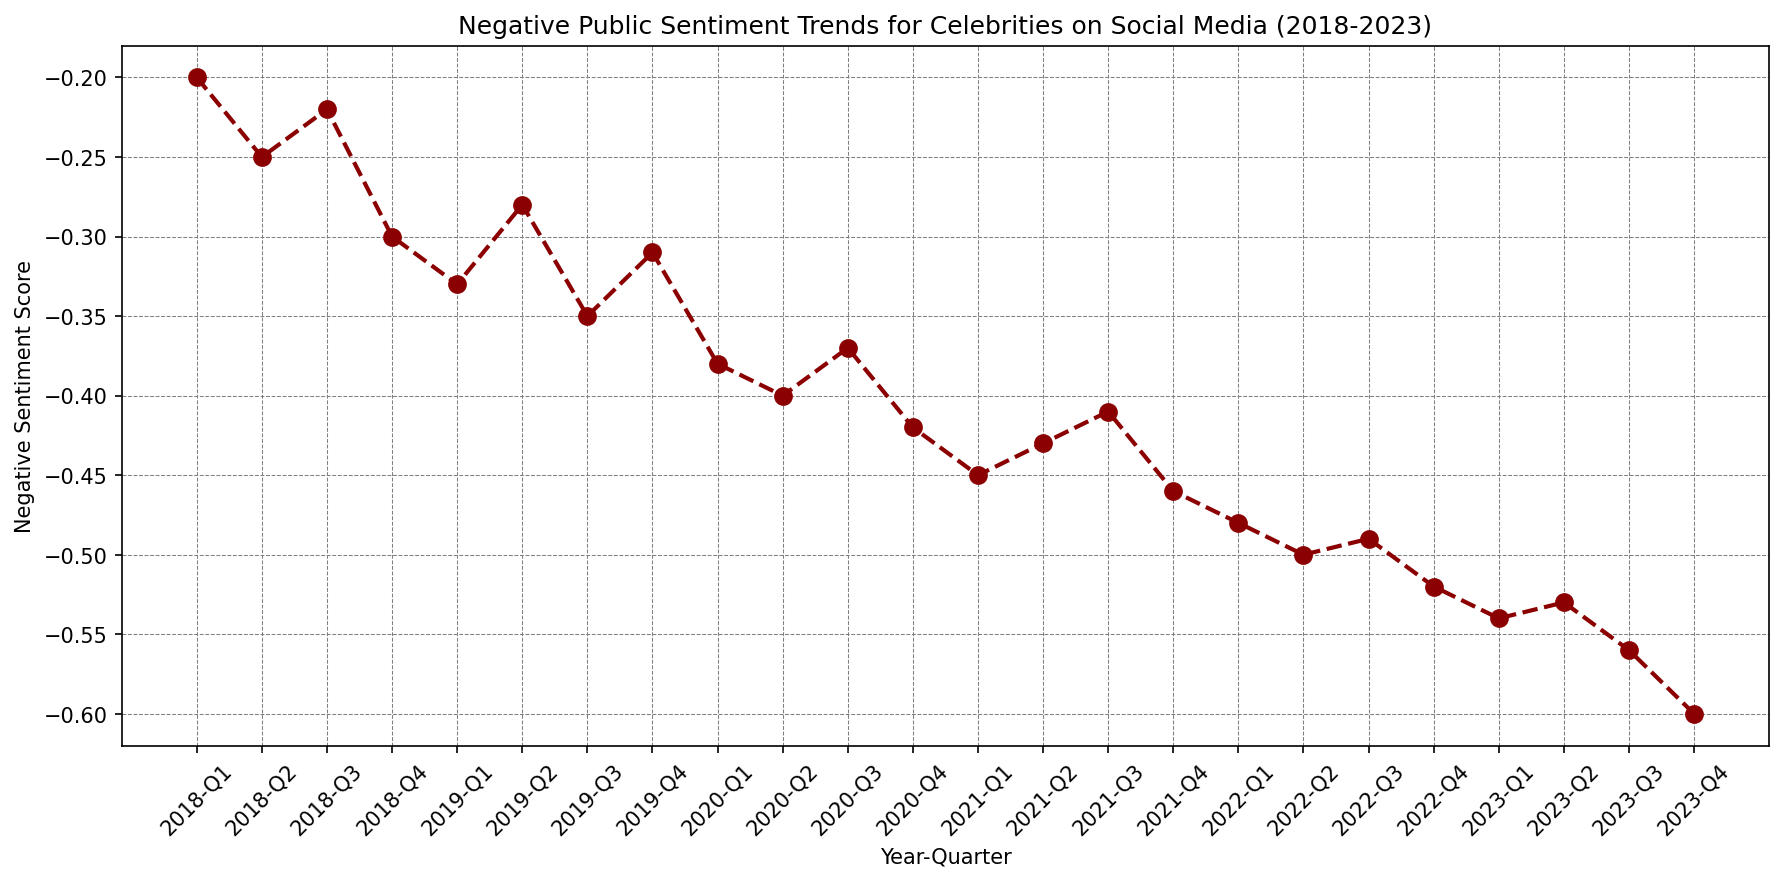what trend do you observe from Q1 2018 to Q4 2019? By visually examining the line from Q1 2018 to Q4 2019, the negative sentiment score starts at -0.20 and reaches -0.31 by Q4 2019, showing an increasing trend (i.e., becoming more negative).
Answer: Increasing trend what happened to the negative sentiment score in Q1 2020? The sentiment score in Q1 2020 is -0.38. To find the change from the previous quarter (Q4 2019, which was -0.31), subtract -0.31 from -0.38. This shows an increase in negative sentiment.
Answer: Increased to -0.38 When did the negative sentiment score first reach -0.50? To find the first instance when the negative sentiment score reached -0.50, look for the first occurrence in descending order. According to the plot, it happened in Q2 2022.
Answer: Q2 2022 Which quarter had the highest negative sentiment in 2021? To find the quarter with the highest negative sentiment in 2021, compare the four values from 2021: Q1 (-0.45), Q2 (-0.43), Q3 (-0.41), and Q4 (-0.46). The highest negative score is in Q4 2021 with -0.46.
Answer: Q4 2021 In which year did the negative sentiment consistently increase throughout all four quarters? Checking each year individually: 2020 saw increases from -0.31 to -0.42, 2021 from -0.42 to -0.46, and 2023 from -0.53 to -0.60. The year 2023 shows a consistent increase each quarter.
Answer: 2023 What is the average negative sentiment score in 2023? Add the negative sentiment scores for each quarter of 2023 (-0.54, -0.53, -0.56, -0.60), then divide by 4: (-0.54 - 0.53 - 0.56 - 0.60) / 4 = -2.23 / 4 = -0.5575
Answer: -0.56 Which quarter showed the smallest increase in negative sentiment over consecutive quarters? Calculate the difference between each consecutive quarter, and find the smallest increase. For instance, Q1-Q2 2020 (0.40-0.38=0.02), Q1-Q2 2021 (0.45-0.43=0.02). The smallest increase is noted in Q1-Q2 2020 and Q1-Q2 2021 with an increase of 0.02.
Answer: Q1-Q2 2020 & Q1-Q2 2021 What is the general trend in negative sentiment from 2018 to 2023? Observing the plot from 2018 (start at -0.20) to 2023 (end at -0.60), it shows an increasing (more negative) trend over the years.
Answer: Increasing trend 